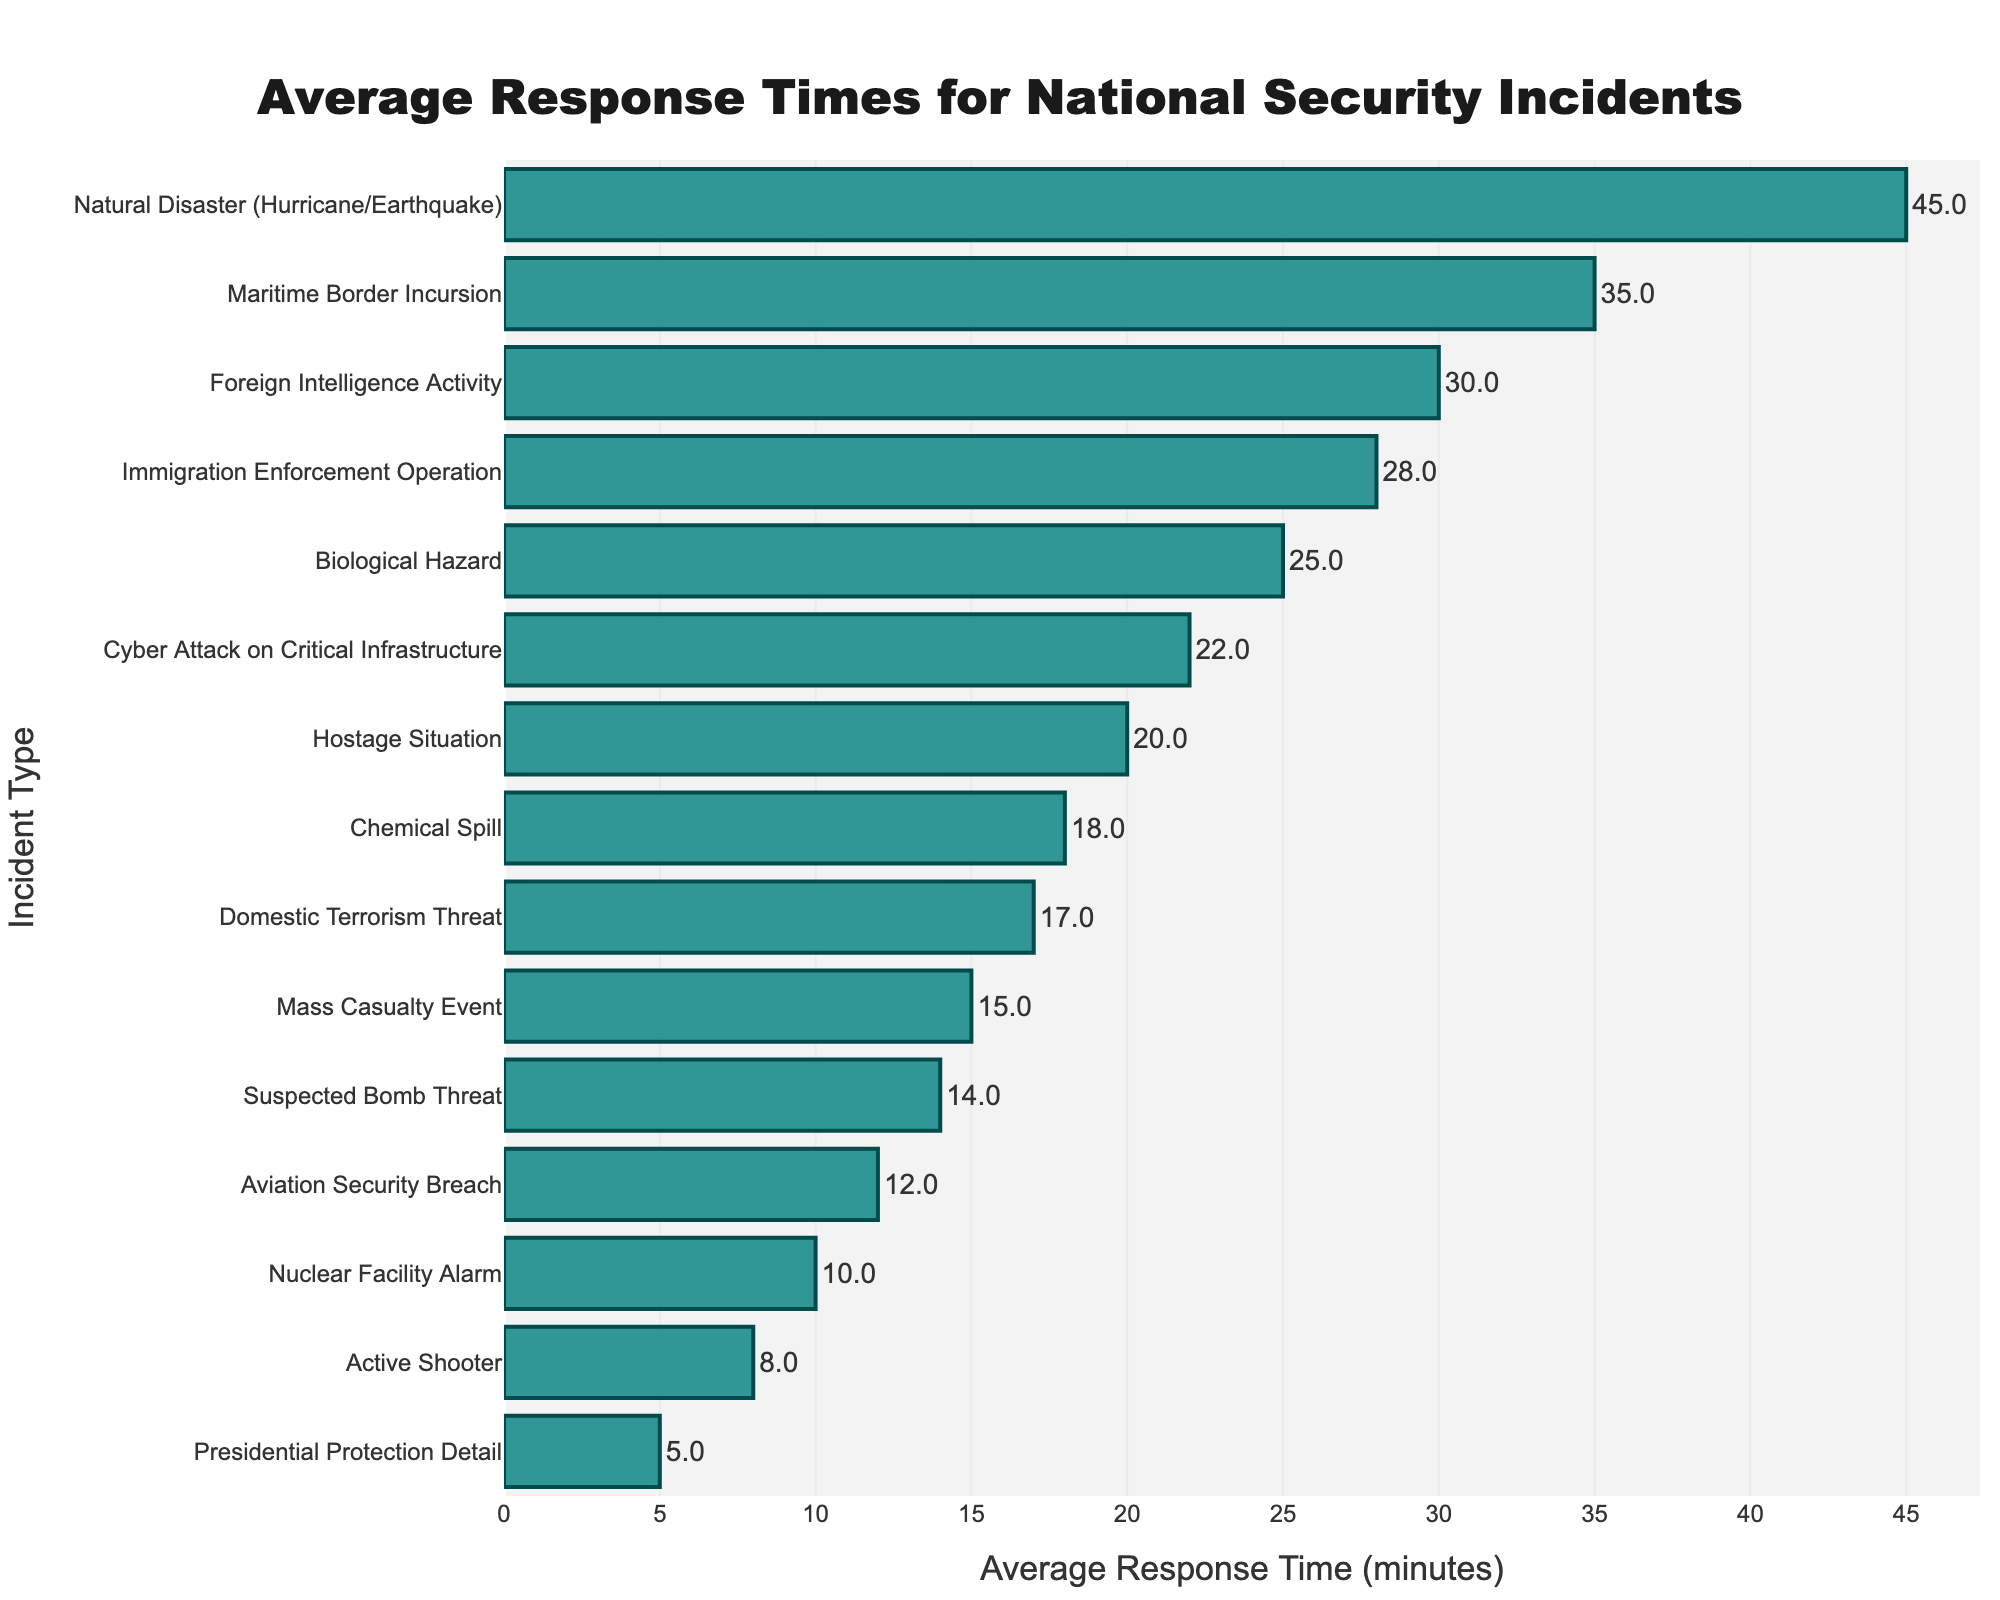Which incident type has the longest average response time? The longest bar represents the longest average response time. The Natural Disaster (Hurricane/Earthquake) bar is the longest.
Answer: Natural Disaster (Hurricane/Earthquake) Which incident type has the shortest average response time? The shortest bar represents the shortest average response time. The Presidential Protection Detail bar is the shortest.
Answer: Presidential Protection Detail What is the difference in average response time between a Natural Disaster (Hurricane/Earthquake) and an Active Shooter incident? Locate the bars for Natural Disaster (45 minutes) and Active Shooter (8 minutes), then subtract the latter from the former (45 - 8).
Answer: 37 minutes How many incident types have an average response time greater than 20 minutes? Count the number of bars with values exceeding 20 minutes. Incident types: Cyber Attack on Critical Infrastructure, Biological Hazard, Maritime Border Incursion, Foreign Intelligence Activity, Immigration Enforcement Operation, Natural Disaster.
Answer: 6 What is the total average response time for Cyber Attack on Critical Infrastructure, Hostage Situation, and Domestic Terrorism Threat incidents? Add the response times for these incidents: Cyber Attack on Critical Infrastructure (22) + Hostage Situation (20) + Domestic Terrorism Threat (17).
Answer: 59 minutes How does the average response time of a Mass Casualty Event compare to an Aviation Security Breach? Compare the lengths of the bars for Mass Casualty Event (15 minutes) and Aviation Security Breach (12 minutes). Mass Casualty Event is longer.
Answer: Mass Casualty Event is longer Which incident has a shorter average response time: a Chemical Spill or a Nuclear Facility Alarm? Compare the lengths of the bars for Chemical Spill (18 minutes) and Nuclear Facility Alarm (10 minutes). Nuclear Facility Alarm is shorter.
Answer: Nuclear Facility Alarm What is the average response time for incidents involving environmental hazards (Chemical Spill, Biological Hazard, Natural Disaster)? Add the response times for these incidents and divide by the number of incidents: (Chemical Spill (18) + Biological Hazard (25) + Natural Disaster (45))/3.
Answer: 29.33 minutes Which incident type has an average response time closest to the median of all the listed incident types? Find the median value of all response times listed and identify the incident type closest to it. With 15 values, the median is the 8th value when ordered: Chemical Spill (18 minutes).
Answer: Chemical Spill 